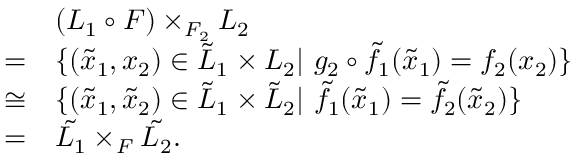<formula> <loc_0><loc_0><loc_500><loc_500>\begin{array} { r l } & { ( L _ { 1 } \circ F ) \times _ { F _ { 2 } } L _ { 2 } } \\ { = } & { \{ ( \tilde { x } _ { 1 } , x _ { 2 } ) \in \tilde { L } _ { 1 } \times L _ { 2 } | \ g _ { 2 } \circ \tilde { f _ { 1 } } ( \tilde { x } _ { 1 } ) = f _ { 2 } ( x _ { 2 } ) \} } \\ { \cong } & { \{ ( \tilde { x } _ { 1 } , \tilde { x } _ { 2 } ) \in \tilde { L } _ { 1 } \times \tilde { L } _ { 2 } | \ \tilde { f _ { 1 } } ( \tilde { x } _ { 1 } ) = \tilde { f _ { 2 } } ( \tilde { x } _ { 2 } ) \} } \\ { = } & { \tilde { L _ { 1 } } \times _ { F } \tilde { L _ { 2 } } . } \end{array}</formula> 